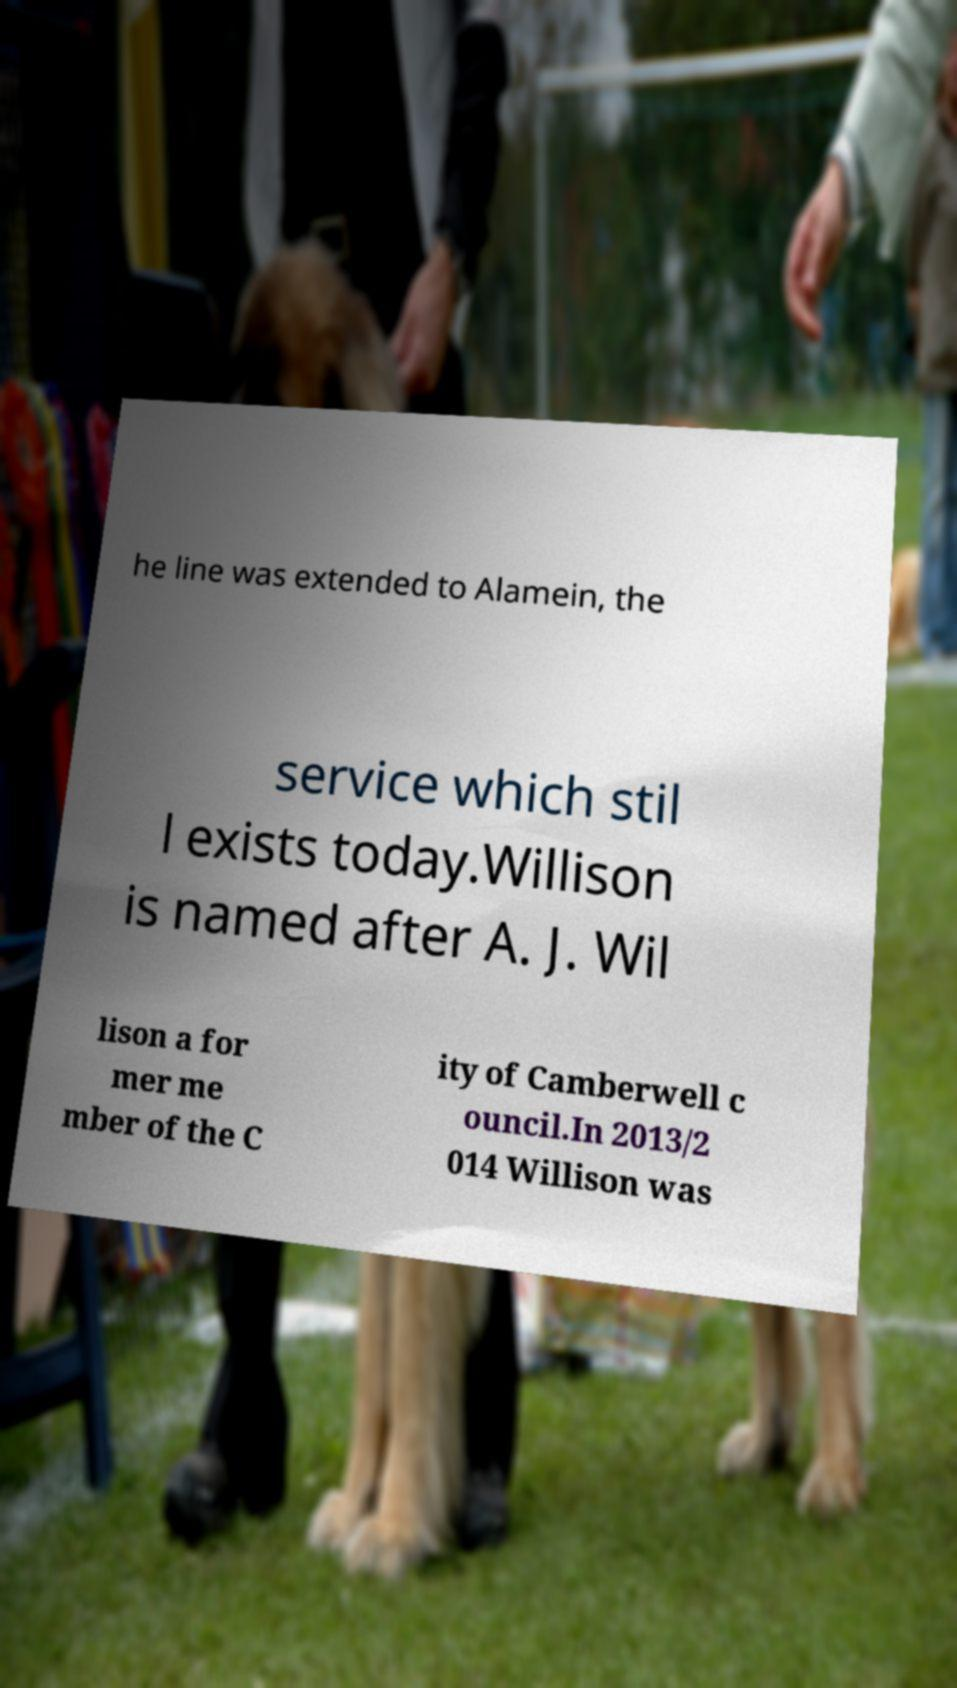Can you read and provide the text displayed in the image?This photo seems to have some interesting text. Can you extract and type it out for me? he line was extended to Alamein, the service which stil l exists today.Willison is named after A. J. Wil lison a for mer me mber of the C ity of Camberwell c ouncil.In 2013/2 014 Willison was 